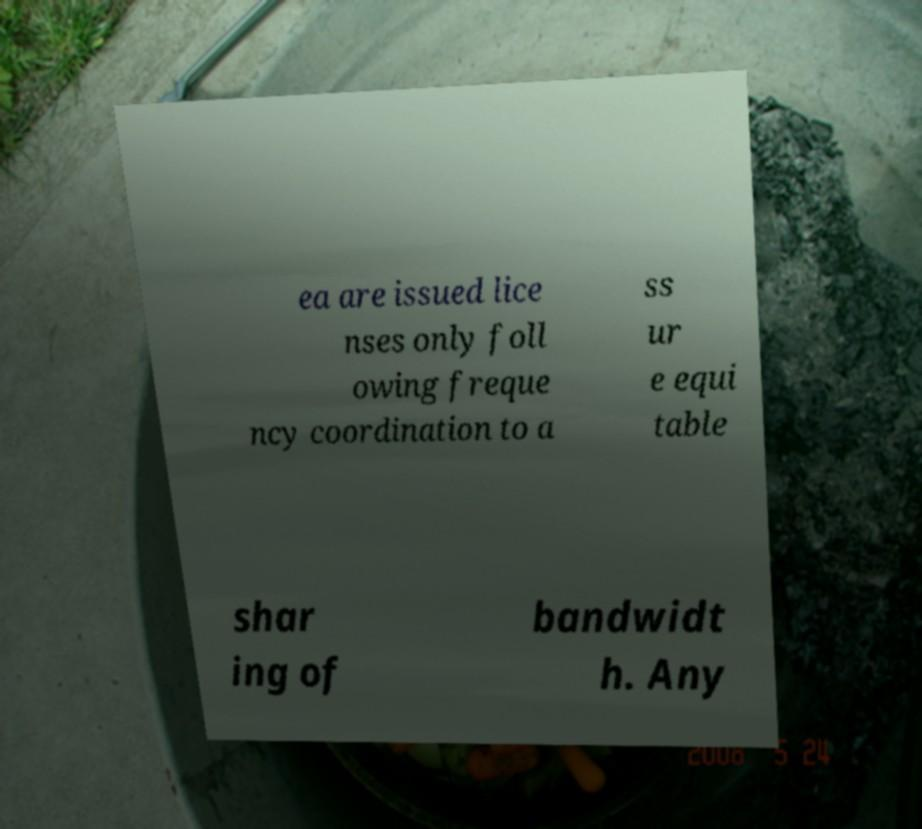What messages or text are displayed in this image? I need them in a readable, typed format. ea are issued lice nses only foll owing freque ncy coordination to a ss ur e equi table shar ing of bandwidt h. Any 